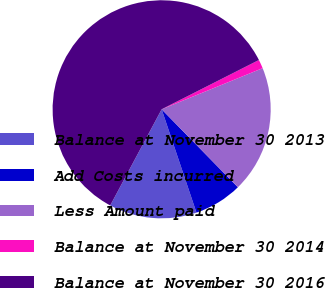Convert chart to OTSL. <chart><loc_0><loc_0><loc_500><loc_500><pie_chart><fcel>Balance at November 30 2013<fcel>Add Costs incurred<fcel>Less Amount paid<fcel>Balance at November 30 2014<fcel>Balance at November 30 2016<nl><fcel>12.99%<fcel>7.15%<fcel>18.83%<fcel>1.31%<fcel>59.71%<nl></chart> 